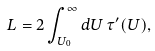<formula> <loc_0><loc_0><loc_500><loc_500>L = 2 \int _ { U _ { 0 } } ^ { \infty } d U \, \tau ^ { \prime } ( U ) ,</formula> 